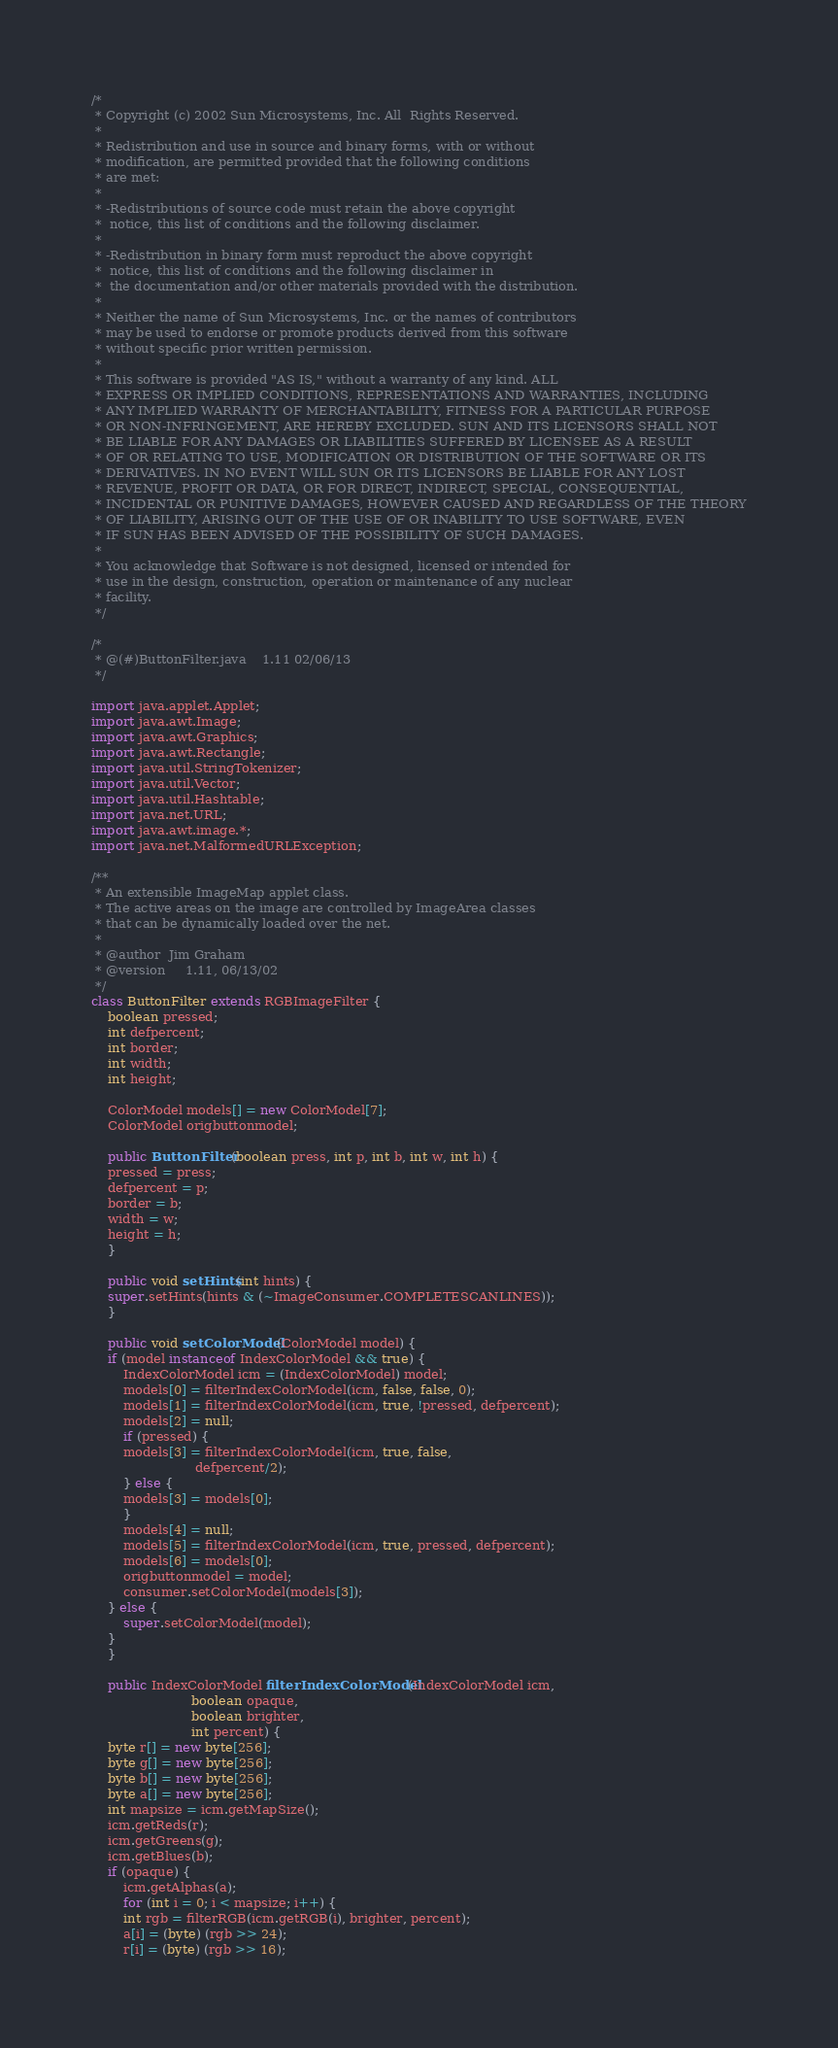Convert code to text. <code><loc_0><loc_0><loc_500><loc_500><_Java_>/*
 * Copyright (c) 2002 Sun Microsystems, Inc. All  Rights Reserved.
 * 
 * Redistribution and use in source and binary forms, with or without
 * modification, are permitted provided that the following conditions
 * are met:
 * 
 * -Redistributions of source code must retain the above copyright
 *  notice, this list of conditions and the following disclaimer.
 * 
 * -Redistribution in binary form must reproduct the above copyright
 *  notice, this list of conditions and the following disclaimer in
 *  the documentation and/or other materials provided with the distribution.
 * 
 * Neither the name of Sun Microsystems, Inc. or the names of contributors
 * may be used to endorse or promote products derived from this software
 * without specific prior written permission.
 * 
 * This software is provided "AS IS," without a warranty of any kind. ALL
 * EXPRESS OR IMPLIED CONDITIONS, REPRESENTATIONS AND WARRANTIES, INCLUDING
 * ANY IMPLIED WARRANTY OF MERCHANTABILITY, FITNESS FOR A PARTICULAR PURPOSE
 * OR NON-INFRINGEMENT, ARE HEREBY EXCLUDED. SUN AND ITS LICENSORS SHALL NOT
 * BE LIABLE FOR ANY DAMAGES OR LIABILITIES SUFFERED BY LICENSEE AS A RESULT
 * OF OR RELATING TO USE, MODIFICATION OR DISTRIBUTION OF THE SOFTWARE OR ITS
 * DERIVATIVES. IN NO EVENT WILL SUN OR ITS LICENSORS BE LIABLE FOR ANY LOST
 * REVENUE, PROFIT OR DATA, OR FOR DIRECT, INDIRECT, SPECIAL, CONSEQUENTIAL,
 * INCIDENTAL OR PUNITIVE DAMAGES, HOWEVER CAUSED AND REGARDLESS OF THE THEORY
 * OF LIABILITY, ARISING OUT OF THE USE OF OR INABILITY TO USE SOFTWARE, EVEN
 * IF SUN HAS BEEN ADVISED OF THE POSSIBILITY OF SUCH DAMAGES.
 * 
 * You acknowledge that Software is not designed, licensed or intended for
 * use in the design, construction, operation or maintenance of any nuclear
 * facility.
 */

/*
 * @(#)ButtonFilter.java	1.11 02/06/13
 */

import java.applet.Applet;
import java.awt.Image;
import java.awt.Graphics;
import java.awt.Rectangle;
import java.util.StringTokenizer;
import java.util.Vector;
import java.util.Hashtable;
import java.net.URL;
import java.awt.image.*;
import java.net.MalformedURLException;

/**
 * An extensible ImageMap applet class.
 * The active areas on the image are controlled by ImageArea classes
 * that can be dynamically loaded over the net.
 *
 * @author 	Jim Graham
 * @version 	1.11, 06/13/02
 */
class ButtonFilter extends RGBImageFilter {
    boolean pressed;
    int defpercent;
    int border;
    int width;
    int height;

    ColorModel models[] = new ColorModel[7];
    ColorModel origbuttonmodel;

    public ButtonFilter(boolean press, int p, int b, int w, int h) {
	pressed = press;
	defpercent = p;
	border = b;
	width = w;
	height = h;
    }

    public void setHints(int hints) {
	super.setHints(hints & (~ImageConsumer.COMPLETESCANLINES));
    }

    public void setColorModel(ColorModel model) {
	if (model instanceof IndexColorModel && true) {
	    IndexColorModel icm = (IndexColorModel) model;
	    models[0] = filterIndexColorModel(icm, false, false, 0);
	    models[1] = filterIndexColorModel(icm, true, !pressed, defpercent);
	    models[2] = null;
	    if (pressed) {
		models[3] = filterIndexColorModel(icm, true, false,
						  defpercent/2);
	    } else {
		models[3] = models[0];
	    }
	    models[4] = null;
	    models[5] = filterIndexColorModel(icm, true, pressed, defpercent);
	    models[6] = models[0];
	    origbuttonmodel = model;
	    consumer.setColorModel(models[3]);
	} else {
	    super.setColorModel(model);
	}
    }

    public IndexColorModel filterIndexColorModel(IndexColorModel icm,
						 boolean opaque,
						 boolean brighter,
						 int percent) {
	byte r[] = new byte[256];
	byte g[] = new byte[256];
	byte b[] = new byte[256];
	byte a[] = new byte[256];
	int mapsize = icm.getMapSize();
	icm.getReds(r);
	icm.getGreens(g);
	icm.getBlues(b);
	if (opaque) {
	    icm.getAlphas(a);
	    for (int i = 0; i < mapsize; i++) {
		int rgb = filterRGB(icm.getRGB(i), brighter, percent);
		a[i] = (byte) (rgb >> 24);
		r[i] = (byte) (rgb >> 16);</code> 